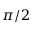Convert formula to latex. <formula><loc_0><loc_0><loc_500><loc_500>\pi / 2</formula> 